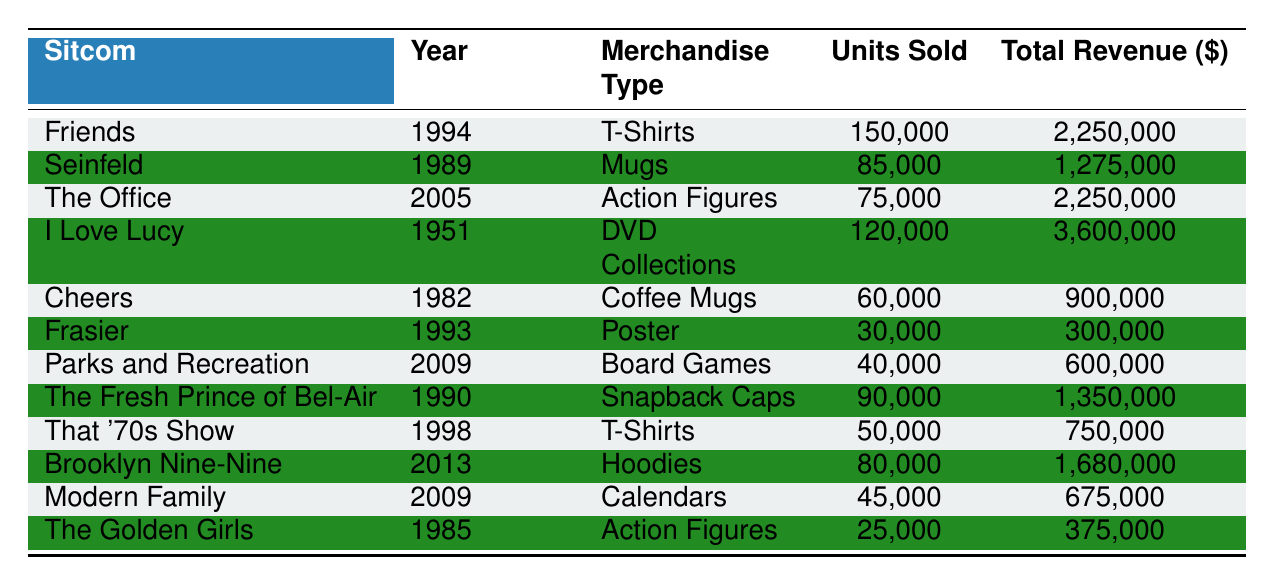What sitcom had the highest merchandise revenue? Looking at the total revenue column, "I Love Lucy" has the highest total revenue listed at $3,600,000.
Answer: I Love Lucy How many units of T-Shirts were sold for "That '70s Show"? Referring to the row for "That '70s Show," it shows that 50,000 units of T-Shirts were sold.
Answer: 50,000 What is the total merchandise revenue for all sitcoms combined from the year 2009? The shows from 2009, "Parks and Recreation" and "Modern Family," have total revenues of $600,000 and $675,000 respectively. Adding these gives $600,000 + $675,000 = $1,275,000.
Answer: 1,275,000 Did "Frasier" sell more than 40,000 units of merchandise? Referring to "Frasier," it shows that 30,000 units were sold, which is less than 40,000.
Answer: No Which sitcom sold the most coffee mugs? The only sitcom that sold coffee mugs is "Cheers" with 60,000 units sold. No other sitcom reported selling coffee mugs.
Answer: Cheers How does the revenue from "The Office" compare to "Friends"? "The Office" had a total revenue of $2,250,000, which is the same as "Friends," whose revenue is also $2,250,000.
Answer: They are the same What is the average number of units sold for all merchandise types combined? To find the average, add all units sold from the table: 150,000 + 85,000 + 75,000 + 120,000 + 60,000 + 30,000 + 40,000 + 90,000 + 50,000 + 80,000 + 45,000 + 25,000 = 735,000. There are 12 entries, so the average is 735,000 / 12 = 61,250.
Answer: 61,250 Is there a merchandise type that is sold in a greater quantity than 100,000 units? By checking the units sold, only the T-Shirts from "Friends" (150,000) and the DVD Collections from "I Love Lucy" (120,000) exceed 100,000 units.
Answer: Yes Which two sitcoms had the lowest merchandise sales in terms of units sold? Looking at the units sold, "The Golden Girls" had 25,000 and "Frasier" had 30,000, making them the two sitcoms with the lowest sales.
Answer: The Golden Girls and Frasier 